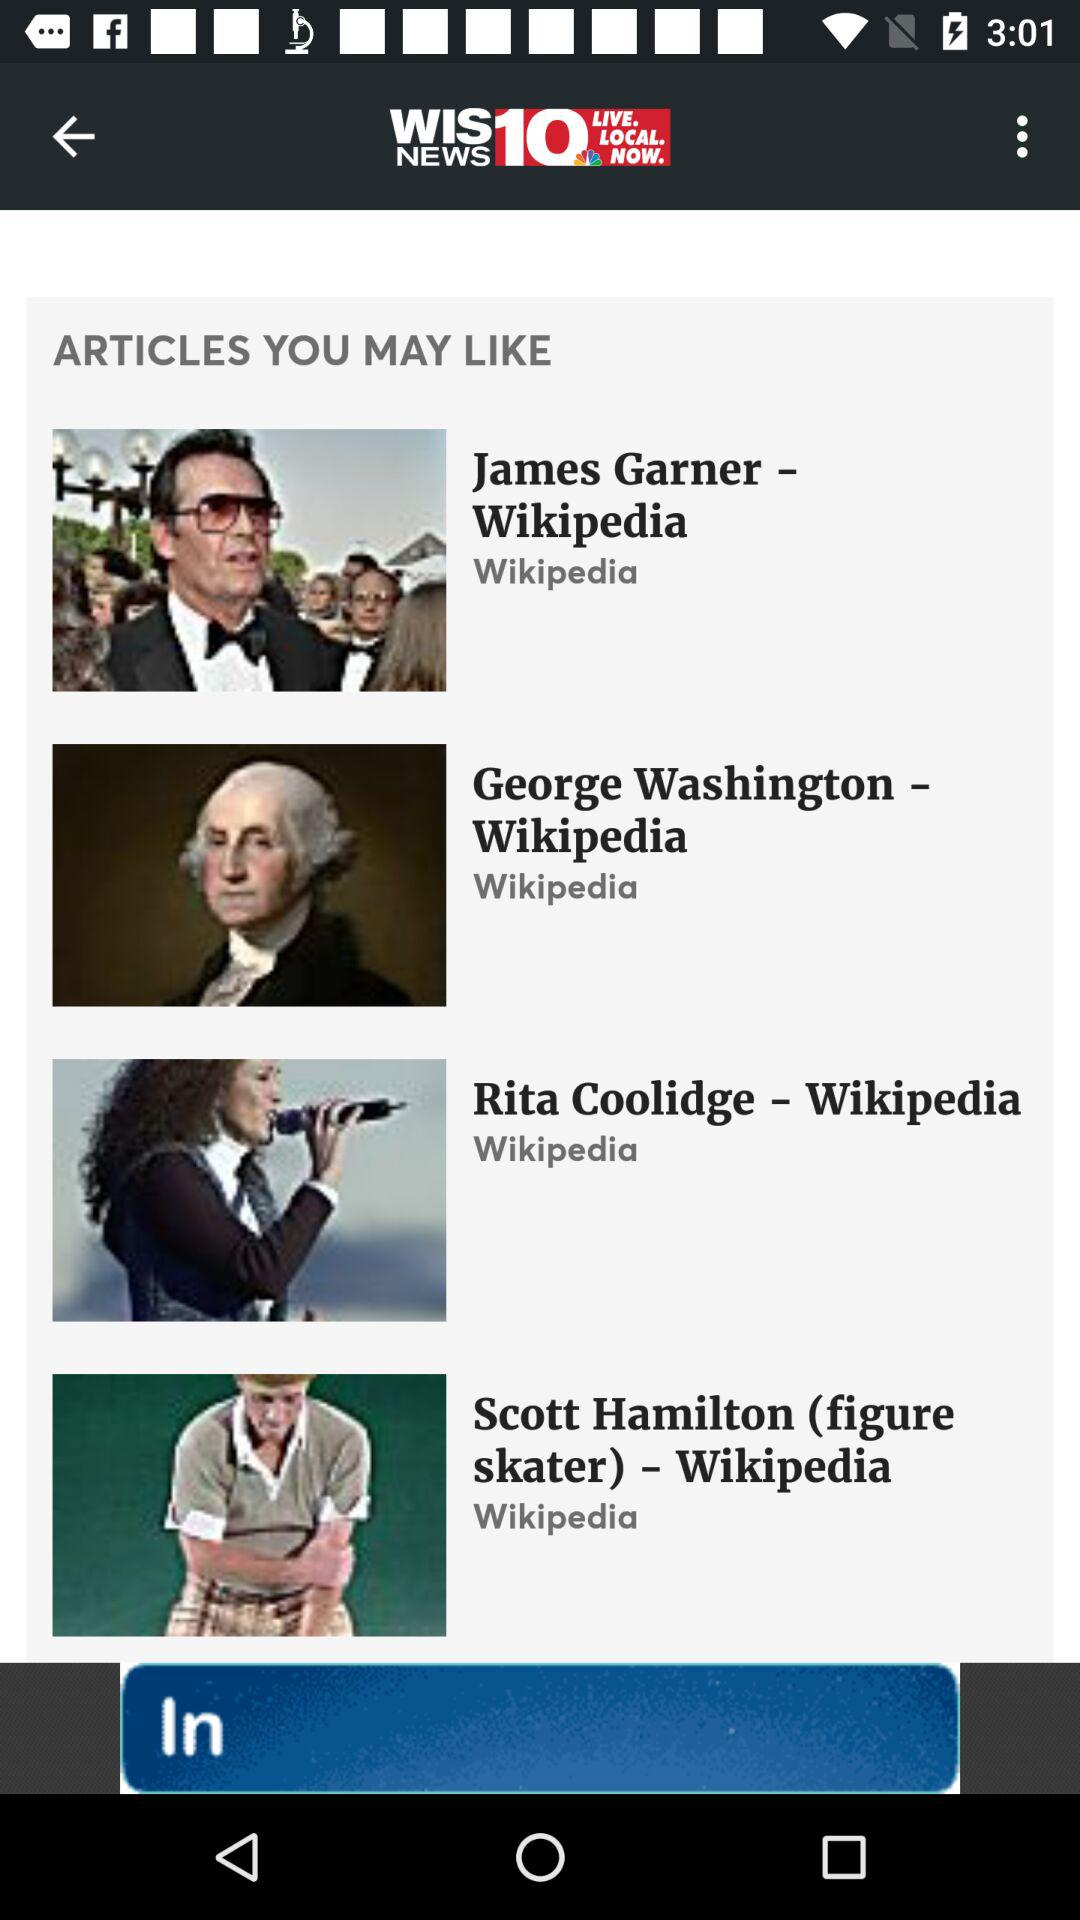How many items are there in the articles you may like section?
Answer the question using a single word or phrase. 4 